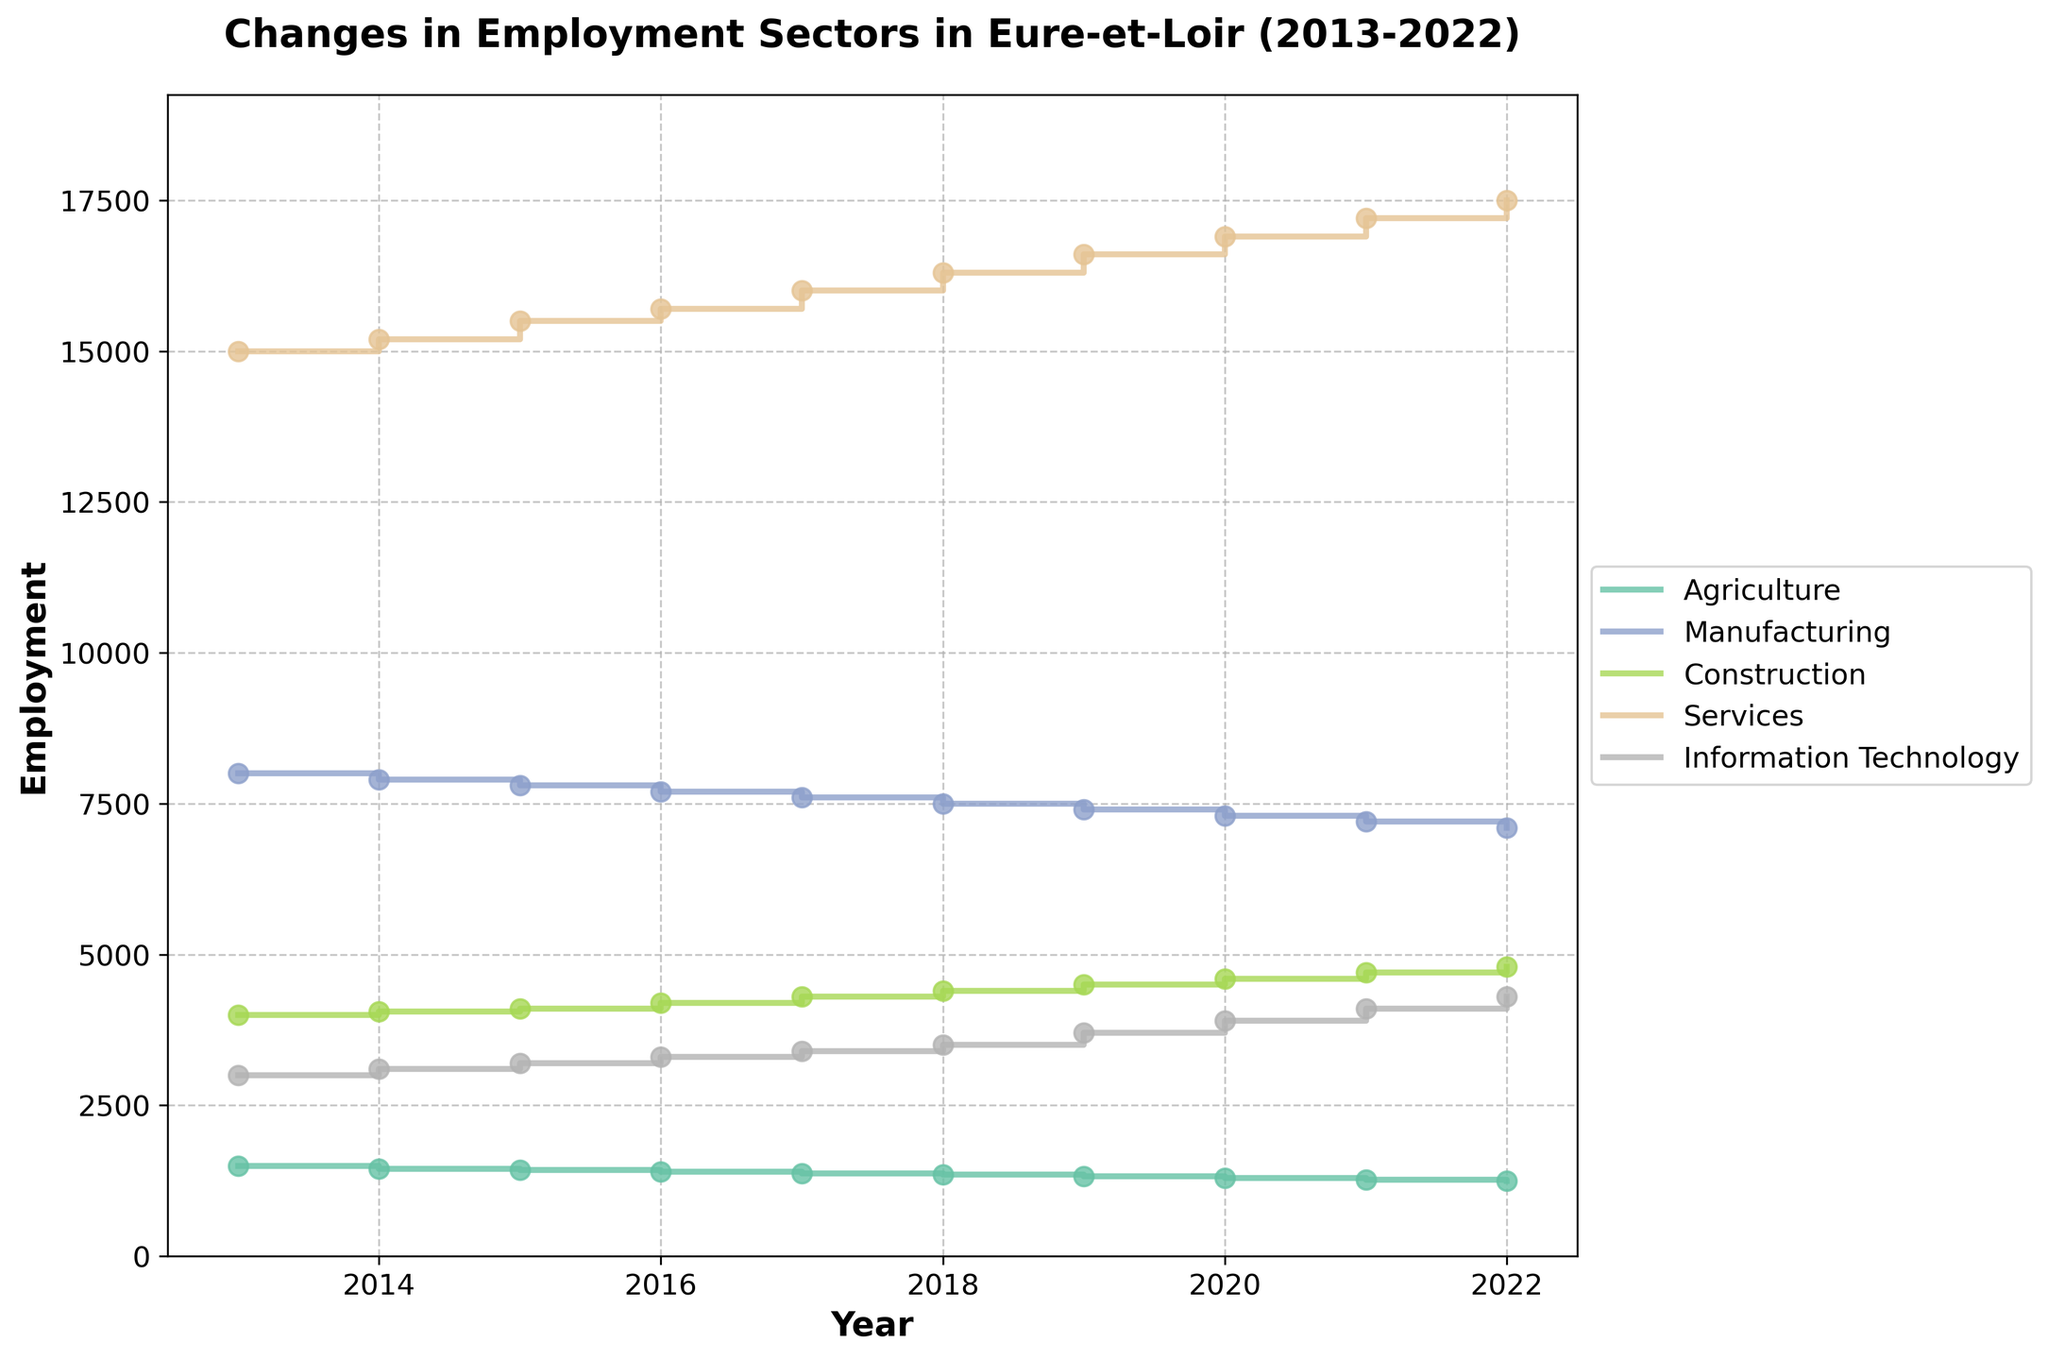what is the total employment in services for the year 2017? To find the total employment in the services sector for 2017, look at the data point where the services line intersects with the year 2017. Here, the value is 16,000.
Answer: 16,000 Which sector had the highest employment in 2022? To determine which sector had the highest employment in 2022, compare the endpoints of the lines in 2022. The services sector has the highest endpoint at 17,500.
Answer: Services How did employment in manufacturing change from 2013 to 2022? The employment in manufacturing in 2013 was 8,000, and in 2022 it was 7,100. Calculate the difference: 8,000 - 7,100 = 900. So, employment decreased by 900 jobs.
Answer: Decreased by 900 Among all sectors, which one shows a consistent increase in employment over the years? To identify a consistent increase, trace each line from 2013 to 2022. The Information Technology sector shows a steady upward trend without any dips.
Answer: Information Technology How much did the employment in the agriculture sector decrease from 2013 to 2019? The employment in agriculture in 2013 was 1,500, and in 2019 it was 1,320. Calculate the difference: 1,500 - 1,320 = 180. So, employment decreased by 180 jobs.
Answer: Decreased by 180 How does the employment in construction in 2020 compare to that in 2014? Employment in construction in 2020 is 4,600, and in 2014 it is 4,050. Therefore, it increased by 550 jobs (4,600 - 4,050 = 550).
Answer: Increased by 550 Which sector experienced the largest absolute change in employment between 2013 and 2022? Calculate the absolute change for each sector:
- Agriculture: 1500 - 1250 = 250
- Manufacturing: 8000 - 7100 = 900
- Construction: 4000 - 4800 = 800
- Services: 15000 - 17500 = 2500
- Information Technology: 3000 - 4300 = 1300
The services sector experienced the largest absolute change with 2,500 jobs.
Answer: Services What was the employment trend for the agriculture sector over the decade? Trace the line representing the agriculture sector from 2013 to 2022, showing a steady decline each year.
Answer: Steady decline In which year did the IT sector employment surpass 4,000? Trace the IT sector line and locate the year where it first surpasses the 4,000 mark. It happens in 2021.
Answer: 2021 